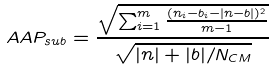<formula> <loc_0><loc_0><loc_500><loc_500>A A P _ { s u b } = \frac { \sqrt { \sum _ { i = 1 } ^ { m } { \frac { ( n _ { i } - b _ { i } - | n - b | ) ^ { 2 } } { m - 1 } } } } { \sqrt { | n | + | b | / N _ { C M } } }</formula> 